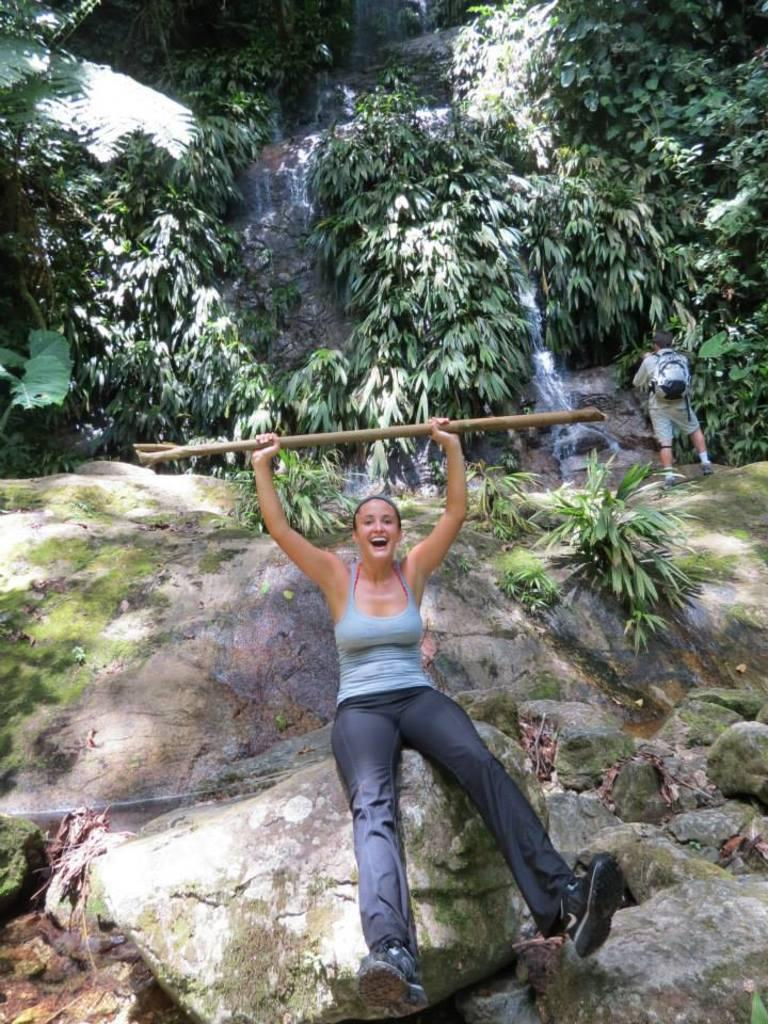What is the person in the image doing? There is a person sitting on a rock in the image. What is the sitting person holding? The person sitting on the rock is holding an object. What is the standing person doing in the image? There is a person standing in the image, and they are carrying a bag. What type of natural features can be seen in the image? There are rocks, plants, and water visible in the image. What type of garden can be seen in the image? There is no garden present in the image. Is the farmer in the image wearing a hat? There is no farmer present in the image. 